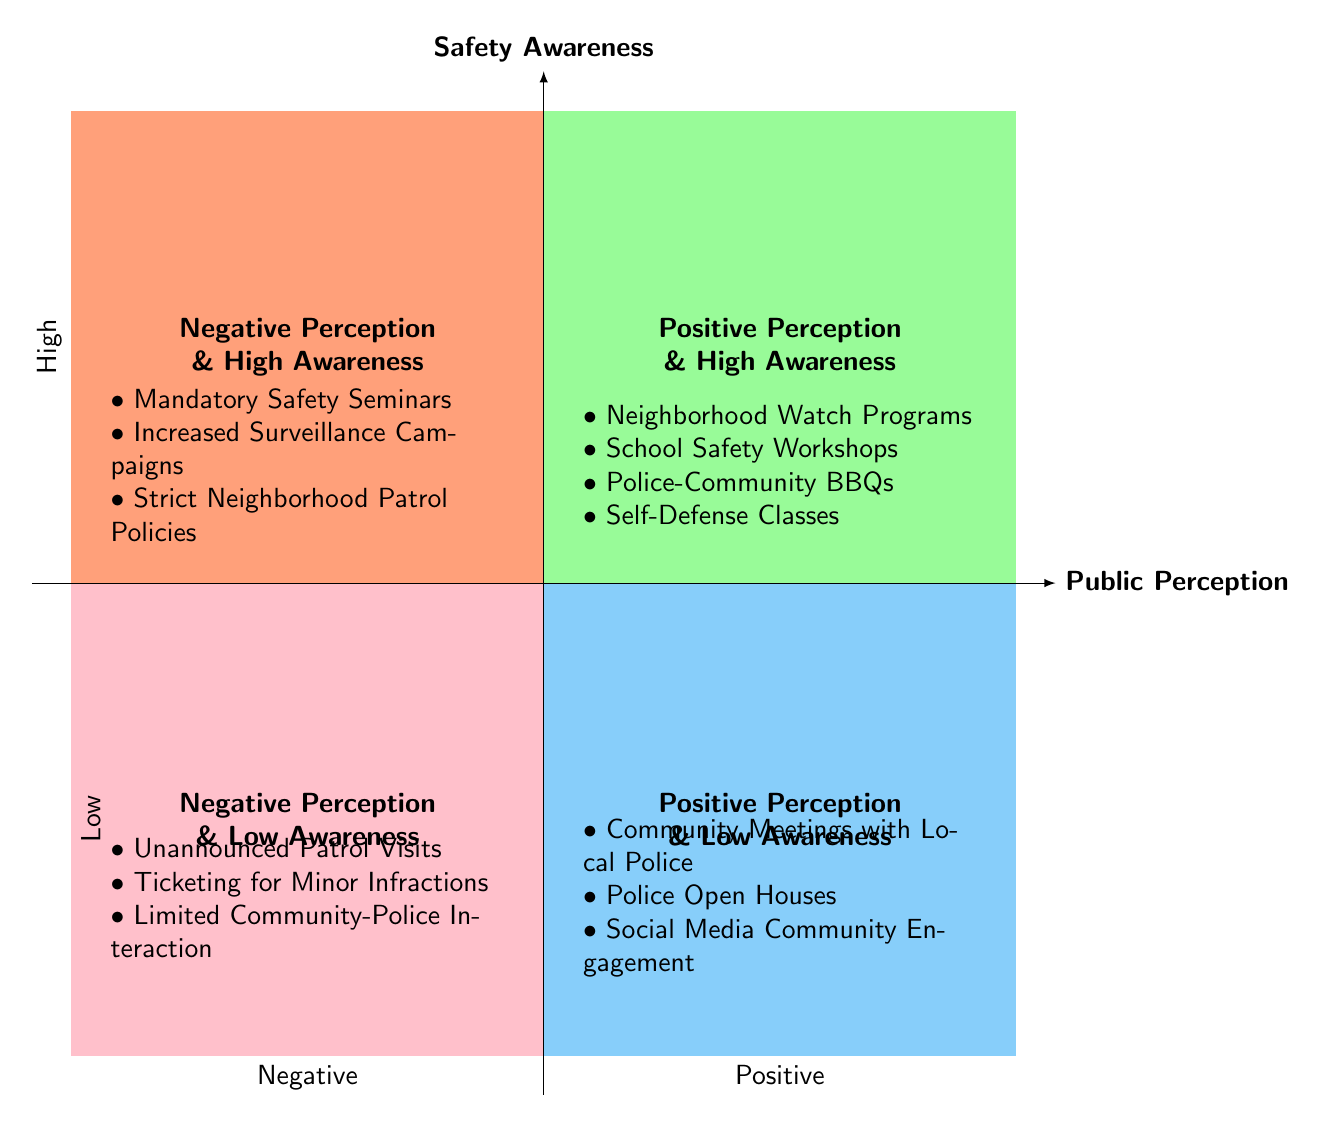What are the elements in the "Positive Perception & High Awareness" quadrant? The "Positive Perception & High Awareness" quadrant contains four specific elements: Neighborhood Watch Programs, School Safety Workshops, Police-Community BBQs, and Self-Defense Classes.
Answer: Neighborhood Watch Programs, School Safety Workshops, Police-Community BBQs, Self-Defense Classes Which quadrant contains "Mandatory Safety Seminars"? "Mandatory Safety Seminars" is found in the "Negative Perception & High Awareness" quadrant, which includes elements that negatively impact public perception despite high awareness.
Answer: Negative Perception & High Awareness How many elements are in the "Positive Perception & Low Awareness" quadrant? The "Positive Perception & Low Awareness" quadrant includes three elements: Community Meetings with Local Police, Police Open Houses, and Social Media Community Engagement, totaling three elements.
Answer: 3 Which quadrant includes elements that negatively affect public perception but achieve high safety awareness? The "Negative Perception & High Awareness" quadrant includes elements such as Mandatory Safety Seminars, which negatively affect public perception while maintaining high safety awareness.
Answer: Negative Perception & High Awareness In which quadrant do you find "Unannounced Patrol Visits"? "Unannounced Patrol Visits" is located in the "Negative Perception & Low Awareness" quadrant, characterized by elements that are neither well-received nor widely recognized by the community.
Answer: Negative Perception & Low Awareness What type of perception is associated with "Police Open Houses"? "Police Open Houses" is associated with "Positive Perception & Low Awareness," indicating that while this activity fosters a positive view of the police, it doesn't lead to high public awareness.
Answer: Positive Perception & Low Awareness How many quadrants have a "High Awareness" classification? There are two quadrants with a "High Awareness" classification: "Positive Perception & High Awareness" and "Negative Perception & High Awareness," making a total of two quadrants.
Answer: 2 What element is present in both "Positive Perception & High Awareness" and "Negative Perception & High Awareness"? There are no elements present in both the "Positive Perception & High Awareness" and "Negative Perception & High Awareness" quadrants, as they contain distinct sets of elements with opposite effects on public perception.
Answer: None Which quadrant would you classify "Social Media Community Engagement"? "Social Media Community Engagement" is classified in the "Positive Perception & Low Awareness" quadrant, as it builds a positive image but may not be widely recognized or understood by the community.
Answer: Positive Perception & Low Awareness 